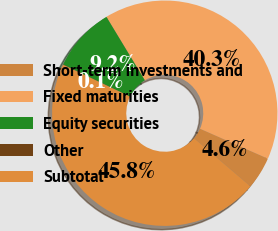<chart> <loc_0><loc_0><loc_500><loc_500><pie_chart><fcel>Short-term investments and<fcel>Fixed maturities<fcel>Equity securities<fcel>Other<fcel>Subtotal<nl><fcel>4.63%<fcel>40.27%<fcel>9.21%<fcel>0.05%<fcel>45.83%<nl></chart> 